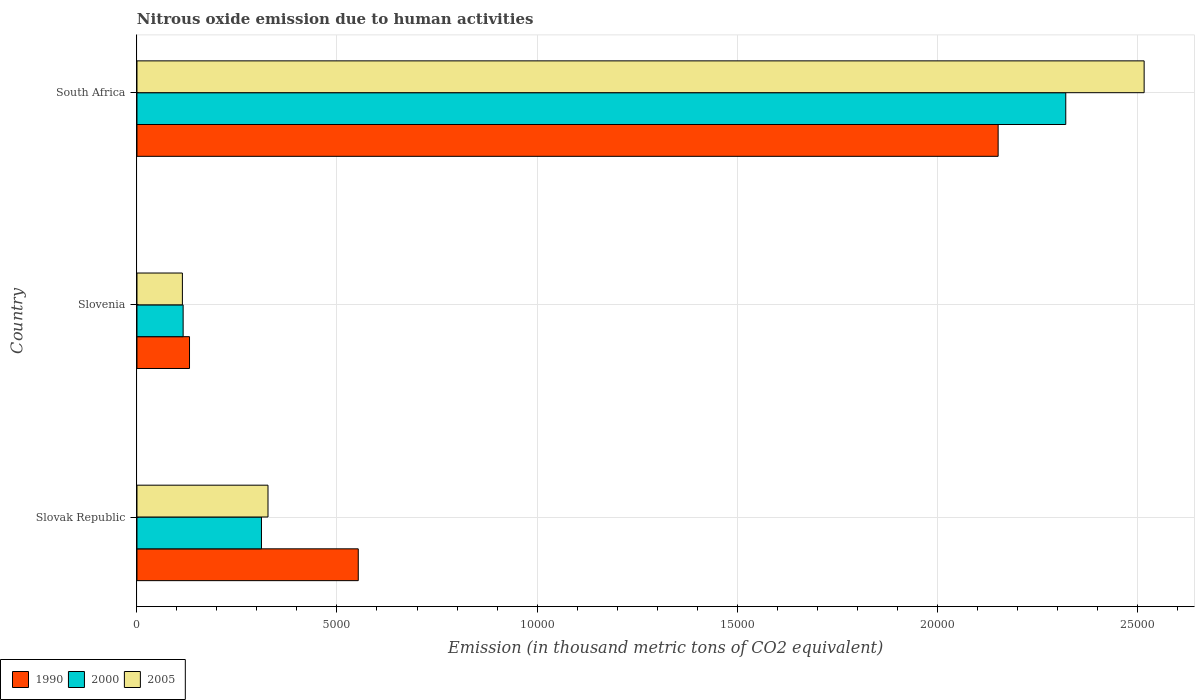How many different coloured bars are there?
Your answer should be very brief. 3. How many bars are there on the 1st tick from the bottom?
Offer a terse response. 3. What is the label of the 2nd group of bars from the top?
Your response must be concise. Slovenia. In how many cases, is the number of bars for a given country not equal to the number of legend labels?
Make the answer very short. 0. What is the amount of nitrous oxide emitted in 1990 in South Africa?
Keep it short and to the point. 2.15e+04. Across all countries, what is the maximum amount of nitrous oxide emitted in 1990?
Your answer should be compact. 2.15e+04. Across all countries, what is the minimum amount of nitrous oxide emitted in 2000?
Offer a terse response. 1154.3. In which country was the amount of nitrous oxide emitted in 2005 maximum?
Your response must be concise. South Africa. In which country was the amount of nitrous oxide emitted in 2005 minimum?
Provide a succinct answer. Slovenia. What is the total amount of nitrous oxide emitted in 1990 in the graph?
Ensure brevity in your answer.  2.84e+04. What is the difference between the amount of nitrous oxide emitted in 2000 in Slovenia and that in South Africa?
Provide a succinct answer. -2.21e+04. What is the difference between the amount of nitrous oxide emitted in 1990 in South Africa and the amount of nitrous oxide emitted in 2000 in Slovenia?
Your response must be concise. 2.04e+04. What is the average amount of nitrous oxide emitted in 1990 per country?
Make the answer very short. 9457.63. What is the difference between the amount of nitrous oxide emitted in 1990 and amount of nitrous oxide emitted in 2000 in Slovak Republic?
Provide a short and direct response. 2419.6. What is the ratio of the amount of nitrous oxide emitted in 1990 in Slovak Republic to that in Slovenia?
Keep it short and to the point. 4.21. Is the amount of nitrous oxide emitted in 2000 in Slovak Republic less than that in Slovenia?
Ensure brevity in your answer.  No. What is the difference between the highest and the second highest amount of nitrous oxide emitted in 1990?
Your response must be concise. 1.60e+04. What is the difference between the highest and the lowest amount of nitrous oxide emitted in 2005?
Make the answer very short. 2.40e+04. Is the sum of the amount of nitrous oxide emitted in 2005 in Slovak Republic and Slovenia greater than the maximum amount of nitrous oxide emitted in 2000 across all countries?
Your answer should be compact. No. What does the 2nd bar from the top in South Africa represents?
Provide a short and direct response. 2000. What does the 2nd bar from the bottom in South Africa represents?
Your response must be concise. 2000. Is it the case that in every country, the sum of the amount of nitrous oxide emitted in 1990 and amount of nitrous oxide emitted in 2005 is greater than the amount of nitrous oxide emitted in 2000?
Ensure brevity in your answer.  Yes. Are all the bars in the graph horizontal?
Give a very brief answer. Yes. How many countries are there in the graph?
Your answer should be compact. 3. Does the graph contain grids?
Offer a very short reply. Yes. Where does the legend appear in the graph?
Your answer should be very brief. Bottom left. How are the legend labels stacked?
Your answer should be very brief. Horizontal. What is the title of the graph?
Offer a terse response. Nitrous oxide emission due to human activities. What is the label or title of the X-axis?
Make the answer very short. Emission (in thousand metric tons of CO2 equivalent). What is the label or title of the Y-axis?
Your response must be concise. Country. What is the Emission (in thousand metric tons of CO2 equivalent) in 1990 in Slovak Republic?
Ensure brevity in your answer.  5531.9. What is the Emission (in thousand metric tons of CO2 equivalent) in 2000 in Slovak Republic?
Your answer should be very brief. 3112.3. What is the Emission (in thousand metric tons of CO2 equivalent) in 2005 in Slovak Republic?
Your response must be concise. 3275.6. What is the Emission (in thousand metric tons of CO2 equivalent) in 1990 in Slovenia?
Provide a succinct answer. 1313.9. What is the Emission (in thousand metric tons of CO2 equivalent) of 2000 in Slovenia?
Provide a short and direct response. 1154.3. What is the Emission (in thousand metric tons of CO2 equivalent) in 2005 in Slovenia?
Offer a very short reply. 1135.7. What is the Emission (in thousand metric tons of CO2 equivalent) in 1990 in South Africa?
Ensure brevity in your answer.  2.15e+04. What is the Emission (in thousand metric tons of CO2 equivalent) of 2000 in South Africa?
Make the answer very short. 2.32e+04. What is the Emission (in thousand metric tons of CO2 equivalent) in 2005 in South Africa?
Your answer should be compact. 2.52e+04. Across all countries, what is the maximum Emission (in thousand metric tons of CO2 equivalent) of 1990?
Make the answer very short. 2.15e+04. Across all countries, what is the maximum Emission (in thousand metric tons of CO2 equivalent) in 2000?
Your response must be concise. 2.32e+04. Across all countries, what is the maximum Emission (in thousand metric tons of CO2 equivalent) in 2005?
Your answer should be very brief. 2.52e+04. Across all countries, what is the minimum Emission (in thousand metric tons of CO2 equivalent) in 1990?
Your answer should be compact. 1313.9. Across all countries, what is the minimum Emission (in thousand metric tons of CO2 equivalent) in 2000?
Provide a short and direct response. 1154.3. Across all countries, what is the minimum Emission (in thousand metric tons of CO2 equivalent) in 2005?
Your response must be concise. 1135.7. What is the total Emission (in thousand metric tons of CO2 equivalent) in 1990 in the graph?
Your answer should be compact. 2.84e+04. What is the total Emission (in thousand metric tons of CO2 equivalent) in 2000 in the graph?
Ensure brevity in your answer.  2.75e+04. What is the total Emission (in thousand metric tons of CO2 equivalent) in 2005 in the graph?
Your response must be concise. 2.96e+04. What is the difference between the Emission (in thousand metric tons of CO2 equivalent) of 1990 in Slovak Republic and that in Slovenia?
Your response must be concise. 4218. What is the difference between the Emission (in thousand metric tons of CO2 equivalent) in 2000 in Slovak Republic and that in Slovenia?
Your response must be concise. 1958. What is the difference between the Emission (in thousand metric tons of CO2 equivalent) in 2005 in Slovak Republic and that in Slovenia?
Keep it short and to the point. 2139.9. What is the difference between the Emission (in thousand metric tons of CO2 equivalent) of 1990 in Slovak Republic and that in South Africa?
Your answer should be very brief. -1.60e+04. What is the difference between the Emission (in thousand metric tons of CO2 equivalent) of 2000 in Slovak Republic and that in South Africa?
Your answer should be compact. -2.01e+04. What is the difference between the Emission (in thousand metric tons of CO2 equivalent) in 2005 in Slovak Republic and that in South Africa?
Offer a very short reply. -2.19e+04. What is the difference between the Emission (in thousand metric tons of CO2 equivalent) in 1990 in Slovenia and that in South Africa?
Give a very brief answer. -2.02e+04. What is the difference between the Emission (in thousand metric tons of CO2 equivalent) in 2000 in Slovenia and that in South Africa?
Provide a succinct answer. -2.21e+04. What is the difference between the Emission (in thousand metric tons of CO2 equivalent) of 2005 in Slovenia and that in South Africa?
Your answer should be compact. -2.40e+04. What is the difference between the Emission (in thousand metric tons of CO2 equivalent) in 1990 in Slovak Republic and the Emission (in thousand metric tons of CO2 equivalent) in 2000 in Slovenia?
Offer a very short reply. 4377.6. What is the difference between the Emission (in thousand metric tons of CO2 equivalent) of 1990 in Slovak Republic and the Emission (in thousand metric tons of CO2 equivalent) of 2005 in Slovenia?
Provide a short and direct response. 4396.2. What is the difference between the Emission (in thousand metric tons of CO2 equivalent) of 2000 in Slovak Republic and the Emission (in thousand metric tons of CO2 equivalent) of 2005 in Slovenia?
Provide a succinct answer. 1976.6. What is the difference between the Emission (in thousand metric tons of CO2 equivalent) in 1990 in Slovak Republic and the Emission (in thousand metric tons of CO2 equivalent) in 2000 in South Africa?
Give a very brief answer. -1.77e+04. What is the difference between the Emission (in thousand metric tons of CO2 equivalent) of 1990 in Slovak Republic and the Emission (in thousand metric tons of CO2 equivalent) of 2005 in South Africa?
Keep it short and to the point. -1.96e+04. What is the difference between the Emission (in thousand metric tons of CO2 equivalent) of 2000 in Slovak Republic and the Emission (in thousand metric tons of CO2 equivalent) of 2005 in South Africa?
Provide a succinct answer. -2.21e+04. What is the difference between the Emission (in thousand metric tons of CO2 equivalent) of 1990 in Slovenia and the Emission (in thousand metric tons of CO2 equivalent) of 2000 in South Africa?
Keep it short and to the point. -2.19e+04. What is the difference between the Emission (in thousand metric tons of CO2 equivalent) of 1990 in Slovenia and the Emission (in thousand metric tons of CO2 equivalent) of 2005 in South Africa?
Give a very brief answer. -2.39e+04. What is the difference between the Emission (in thousand metric tons of CO2 equivalent) in 2000 in Slovenia and the Emission (in thousand metric tons of CO2 equivalent) in 2005 in South Africa?
Give a very brief answer. -2.40e+04. What is the average Emission (in thousand metric tons of CO2 equivalent) in 1990 per country?
Your response must be concise. 9457.63. What is the average Emission (in thousand metric tons of CO2 equivalent) in 2000 per country?
Your response must be concise. 9161.33. What is the average Emission (in thousand metric tons of CO2 equivalent) in 2005 per country?
Your response must be concise. 9862.6. What is the difference between the Emission (in thousand metric tons of CO2 equivalent) in 1990 and Emission (in thousand metric tons of CO2 equivalent) in 2000 in Slovak Republic?
Offer a very short reply. 2419.6. What is the difference between the Emission (in thousand metric tons of CO2 equivalent) of 1990 and Emission (in thousand metric tons of CO2 equivalent) of 2005 in Slovak Republic?
Make the answer very short. 2256.3. What is the difference between the Emission (in thousand metric tons of CO2 equivalent) in 2000 and Emission (in thousand metric tons of CO2 equivalent) in 2005 in Slovak Republic?
Keep it short and to the point. -163.3. What is the difference between the Emission (in thousand metric tons of CO2 equivalent) in 1990 and Emission (in thousand metric tons of CO2 equivalent) in 2000 in Slovenia?
Offer a terse response. 159.6. What is the difference between the Emission (in thousand metric tons of CO2 equivalent) of 1990 and Emission (in thousand metric tons of CO2 equivalent) of 2005 in Slovenia?
Provide a succinct answer. 178.2. What is the difference between the Emission (in thousand metric tons of CO2 equivalent) of 1990 and Emission (in thousand metric tons of CO2 equivalent) of 2000 in South Africa?
Give a very brief answer. -1690.3. What is the difference between the Emission (in thousand metric tons of CO2 equivalent) of 1990 and Emission (in thousand metric tons of CO2 equivalent) of 2005 in South Africa?
Make the answer very short. -3649.4. What is the difference between the Emission (in thousand metric tons of CO2 equivalent) in 2000 and Emission (in thousand metric tons of CO2 equivalent) in 2005 in South Africa?
Offer a very short reply. -1959.1. What is the ratio of the Emission (in thousand metric tons of CO2 equivalent) of 1990 in Slovak Republic to that in Slovenia?
Offer a terse response. 4.21. What is the ratio of the Emission (in thousand metric tons of CO2 equivalent) of 2000 in Slovak Republic to that in Slovenia?
Make the answer very short. 2.7. What is the ratio of the Emission (in thousand metric tons of CO2 equivalent) of 2005 in Slovak Republic to that in Slovenia?
Give a very brief answer. 2.88. What is the ratio of the Emission (in thousand metric tons of CO2 equivalent) of 1990 in Slovak Republic to that in South Africa?
Give a very brief answer. 0.26. What is the ratio of the Emission (in thousand metric tons of CO2 equivalent) in 2000 in Slovak Republic to that in South Africa?
Keep it short and to the point. 0.13. What is the ratio of the Emission (in thousand metric tons of CO2 equivalent) in 2005 in Slovak Republic to that in South Africa?
Provide a succinct answer. 0.13. What is the ratio of the Emission (in thousand metric tons of CO2 equivalent) of 1990 in Slovenia to that in South Africa?
Offer a very short reply. 0.06. What is the ratio of the Emission (in thousand metric tons of CO2 equivalent) of 2000 in Slovenia to that in South Africa?
Your answer should be very brief. 0.05. What is the ratio of the Emission (in thousand metric tons of CO2 equivalent) of 2005 in Slovenia to that in South Africa?
Offer a very short reply. 0.05. What is the difference between the highest and the second highest Emission (in thousand metric tons of CO2 equivalent) of 1990?
Your answer should be very brief. 1.60e+04. What is the difference between the highest and the second highest Emission (in thousand metric tons of CO2 equivalent) of 2000?
Provide a succinct answer. 2.01e+04. What is the difference between the highest and the second highest Emission (in thousand metric tons of CO2 equivalent) in 2005?
Give a very brief answer. 2.19e+04. What is the difference between the highest and the lowest Emission (in thousand metric tons of CO2 equivalent) in 1990?
Provide a succinct answer. 2.02e+04. What is the difference between the highest and the lowest Emission (in thousand metric tons of CO2 equivalent) of 2000?
Ensure brevity in your answer.  2.21e+04. What is the difference between the highest and the lowest Emission (in thousand metric tons of CO2 equivalent) of 2005?
Your answer should be very brief. 2.40e+04. 